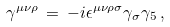<formula> <loc_0><loc_0><loc_500><loc_500>\gamma ^ { \mu \nu \rho } \, = \, - i \epsilon ^ { \mu \nu \rho \sigma } \gamma _ { \sigma } \gamma _ { 5 } \, ,</formula> 